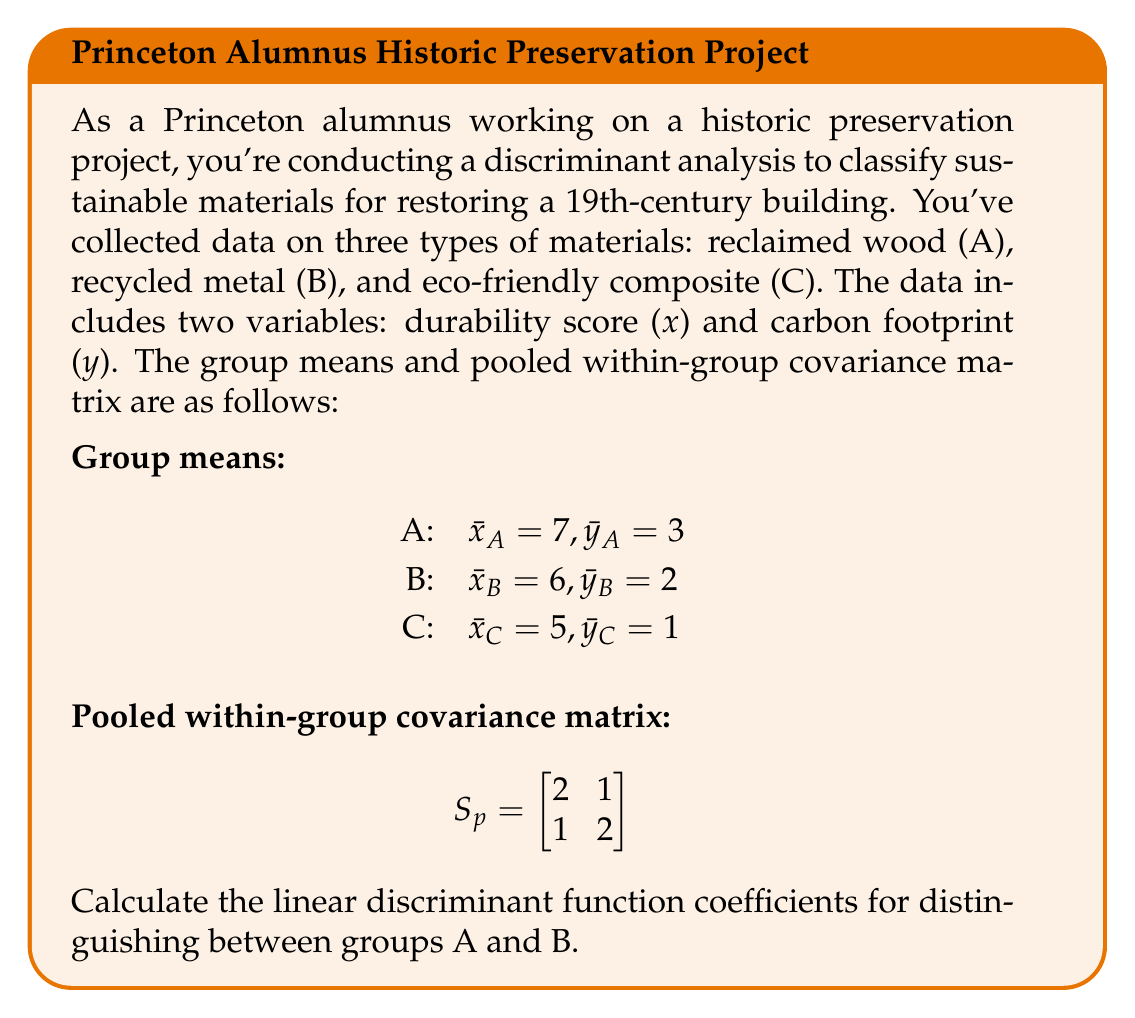What is the answer to this math problem? To calculate the linear discriminant function coefficients for distinguishing between groups A and B, we'll follow these steps:

1) The linear discriminant function has the form:
   $f(x,y) = a_1x + a_2y + c$

2) The coefficients $a_1$ and $a_2$ are calculated using the formula:
   $[a_1, a_2] = (\bar{x}_A - \bar{x}_B, \bar{y}_A - \bar{y}_B)S_p^{-1}$

3) First, let's calculate $(\bar{x}_A - \bar{x}_B, \bar{y}_A - \bar{y}_B)$:
   $(7-6, 3-2) = (1, 1)$

4) Now, we need to find $S_p^{-1}$. The inverse of a 2x2 matrix 
   $\begin{bmatrix} 
   a & b \\
   c & d
   \end{bmatrix}$ 
   is given by:
   $\frac{1}{ad-bc}\begin{bmatrix} 
   d & -b \\
   -c & a
   \end{bmatrix}$

5) Applying this to our $S_p$:
   $S_p^{-1} = \frac{1}{2(2)-1(1)}\begin{bmatrix} 
   2 & -1 \\
   -1 & 2
   \end{bmatrix} = \frac{1}{3}\begin{bmatrix} 
   2 & -1 \\
   -1 & 2
   \end{bmatrix}$

6) Now we can calculate $[a_1, a_2]$:
   $[a_1, a_2] = (1, 1) \frac{1}{3}\begin{bmatrix} 
   2 & -1 \\
   -1 & 2
   \end{bmatrix} = [\frac{1}{3}, \frac{1}{3}]$

7) Therefore, the linear discriminant function is:
   $f(x,y) = \frac{1}{3}x + \frac{1}{3}y + c$

The constant $c$ is not needed for classification purposes, so we don't need to calculate it.
Answer: $[\frac{1}{3}, \frac{1}{3}]$ 